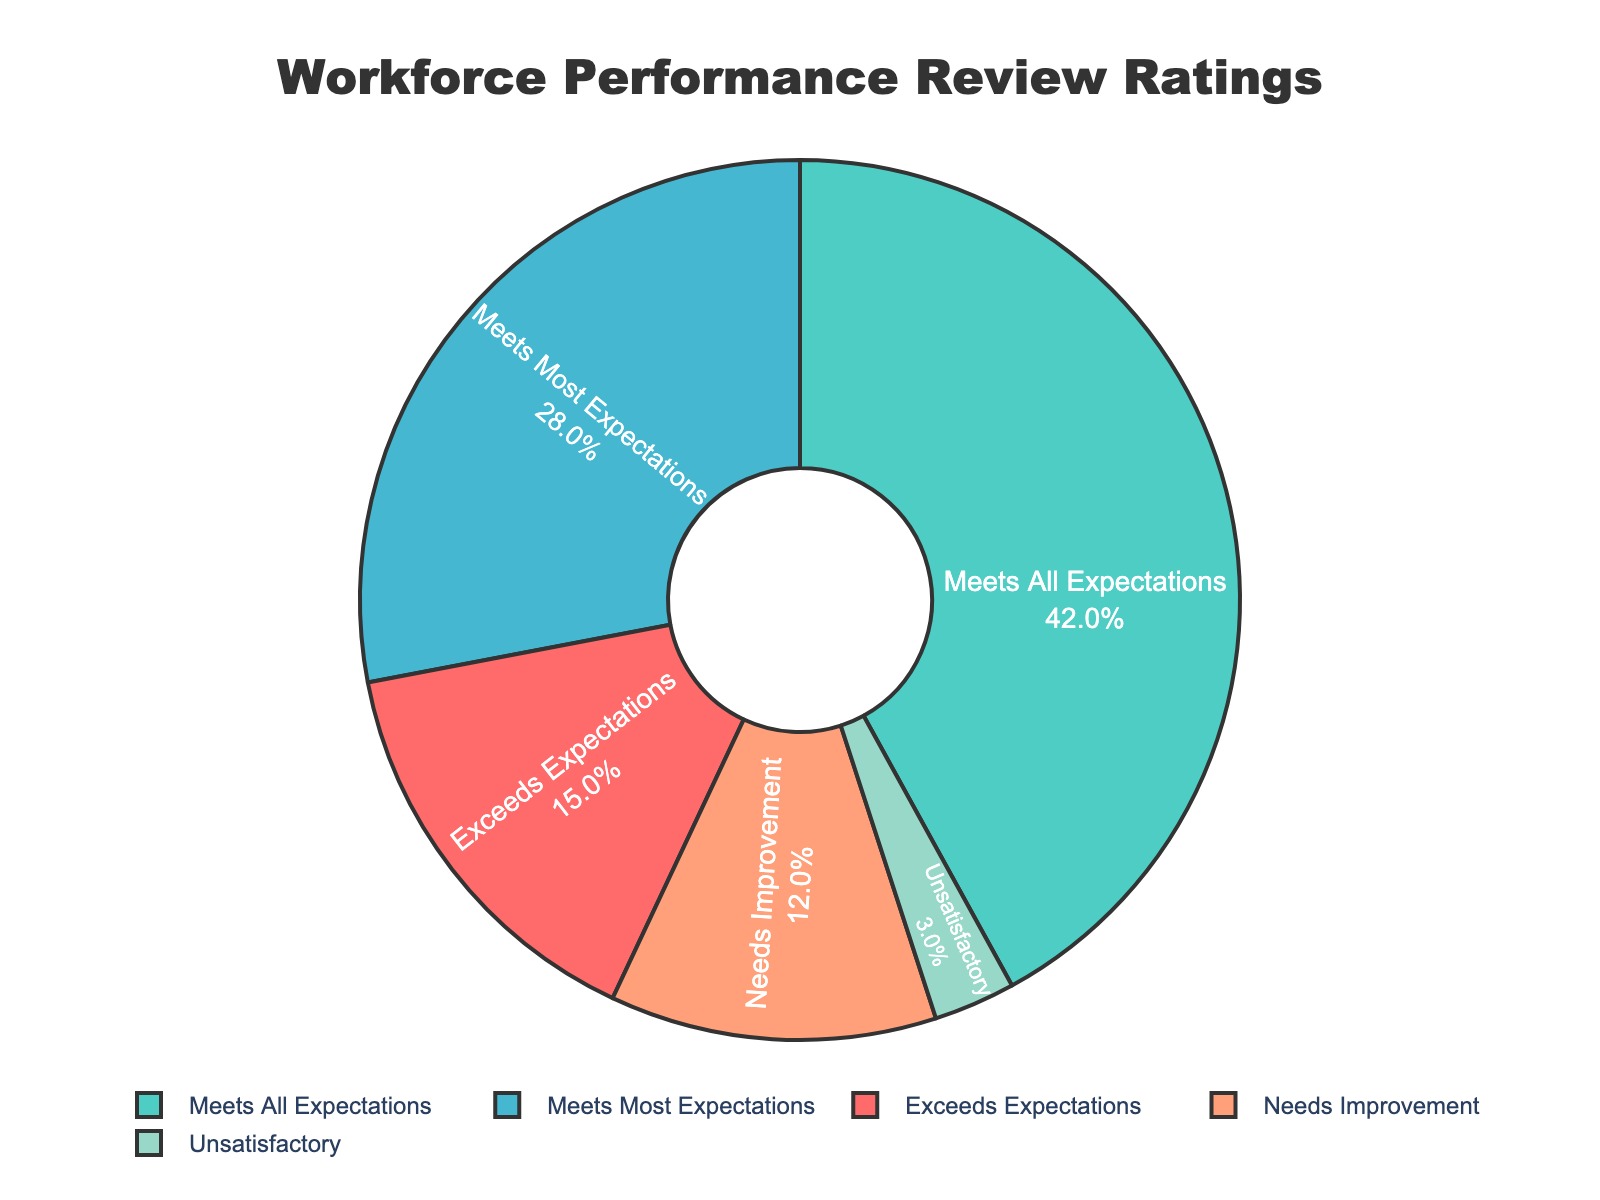What percentage of employees received a rating of "Needs Improvement"? Look at the segment labeled "Needs Improvement" in the pie chart. The value indicated is 12%.
Answer: 12% What is the total percentage of employees who received a rating of "Meets Most Expectations" or better? Sum the percentages of "Meets Most Expectations" (28%), "Meets All Expectations" (42%), and "Exceeds Expectations" (15%): 28% + 42% + 15% = 85%.
Answer: 85% Which rating has the highest percentage of employees? Identify the largest segment on the pie chart. "Meets All Expectations" has the largest portion, shown as 42%.
Answer: Meets All Expectations Is the percentage of employees with a rating of "Unsatisfactory" greater than those with "Exceeds Expectations"? Compare the percentages of "Unsatisfactory" (3%) and "Exceeds Expectations" (15%). Since 3% < 15%, the percentage of "Unsatisfactory" is not greater.
Answer: No What is the combined percentage of employees who need improvement or are unsatisfactory? Add the percentages of "Needs Improvement" (12%) and "Unsatisfactory" (3%): 12% + 3% = 15%.
Answer: 15% Which two ratings combined make up exactly half of the workforce? Sum different combinations of segments until finding the combination that totals 50%. "Meets All Expectations" (42%) and "Needs Improvement" (12%) sum to 54%, while "Meets Most Expectations" (28%) and "Needs Improvement" (12%) sum to 40%. The correct combination is "Meets All Expectations" (42%) and "Meets Most Expectations" (28%): 42% + 28% = 70%. The correct combination is "Meets Most Expectations" (28%) and "Exceeds Expectations" (15%) which sum to 43%. Finally 48 to 52 the best combination is "Meets All Expectations" (42%) and "Meets Most Expectations" (28%)
Answer: 54% What color represents employees who "Exceeds Expectations"? Identify the color of the segment labeled "Exceeds Expectations" on the pie chart. The color is light turquoise.
Answer: Light turquoise How much larger (in percentage points) is the "Meets All Expectations" segment compared to "Needs Improvement"? Subtract the percentage of "Needs Improvement" (12%) from the percentage of "Meets All Expectations" (42%): 42% - 12% = 30%.
Answer: 30% What is the least common rating among the workforce? Find the segment with the smallest percentage. The "Unsatisfactory" segment is the smallest at 3%.
Answer: Unsatisfactory What is the median performance rating category by percentage? List the percentages in order: 3%, 12%, 15%, 28%, 42%. The middle value is 15%, corresponding to "Exceeds Expectations".
Answer: Exceeds Expectations 